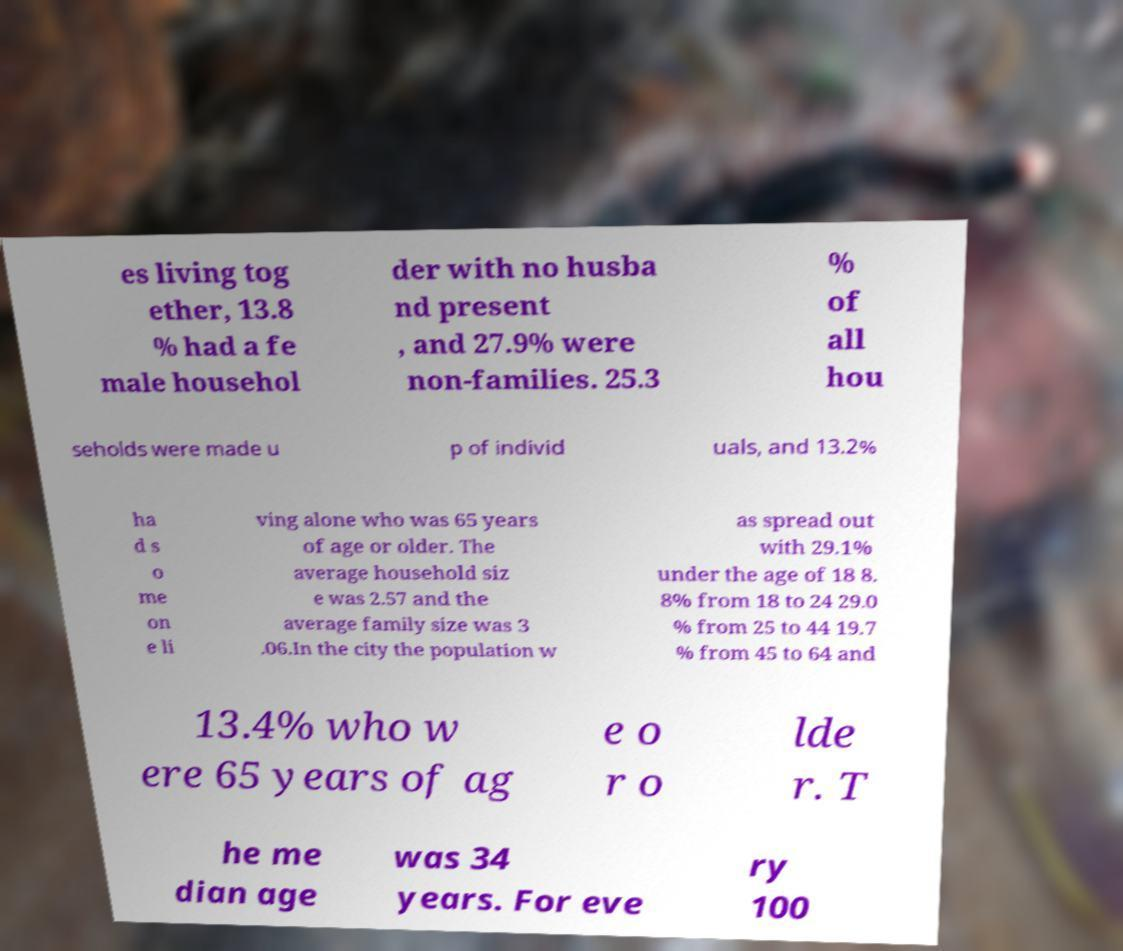Please identify and transcribe the text found in this image. es living tog ether, 13.8 % had a fe male househol der with no husba nd present , and 27.9% were non-families. 25.3 % of all hou seholds were made u p of individ uals, and 13.2% ha d s o me on e li ving alone who was 65 years of age or older. The average household siz e was 2.57 and the average family size was 3 .06.In the city the population w as spread out with 29.1% under the age of 18 8. 8% from 18 to 24 29.0 % from 25 to 44 19.7 % from 45 to 64 and 13.4% who w ere 65 years of ag e o r o lde r. T he me dian age was 34 years. For eve ry 100 